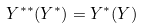Convert formula to latex. <formula><loc_0><loc_0><loc_500><loc_500>Y ^ { * * } ( Y ^ { * } ) = Y ^ { * } ( Y )</formula> 